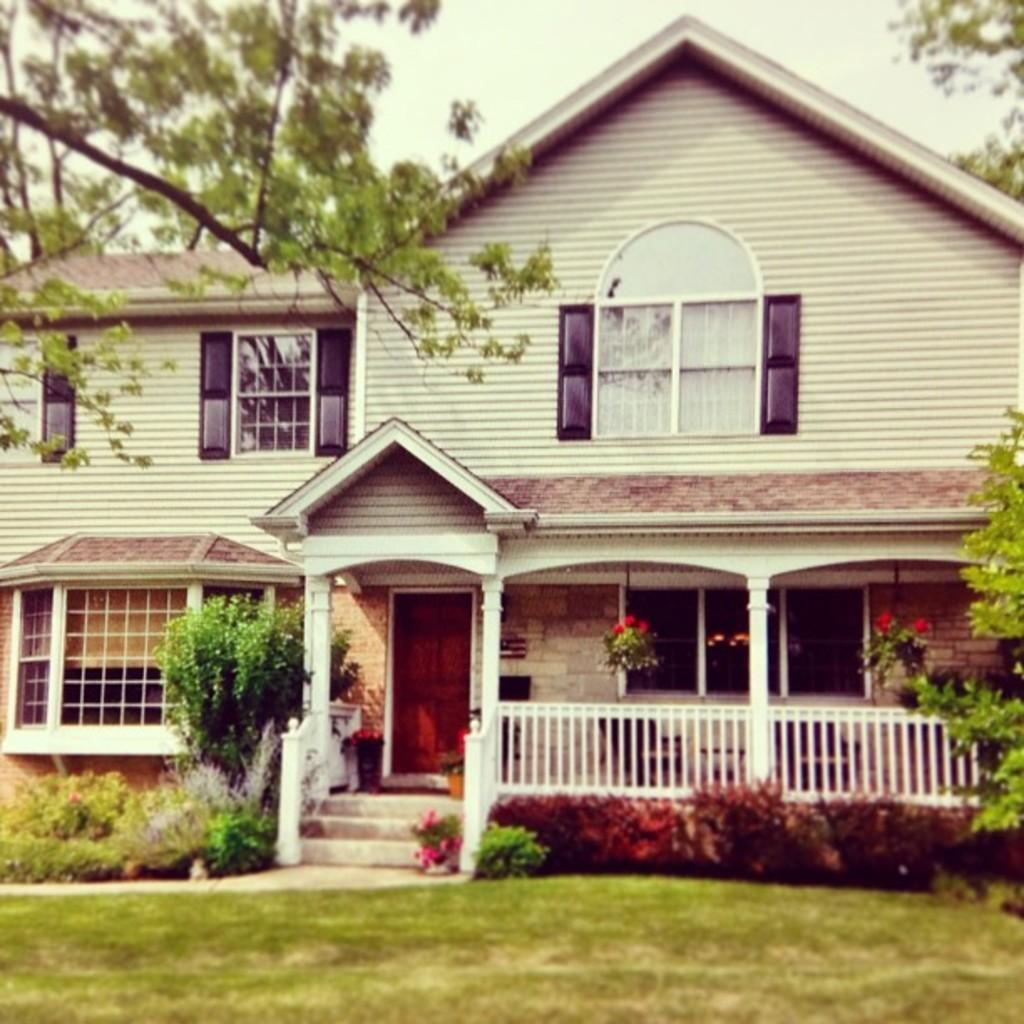What type of vegetation is present on the ground in the front of the image? There is grass on the ground in the front of the image. What can be seen in the background of the image? In the background of the image, there are plants, trees, and a house. What is the condition of the sky in the image? The sky is cloudy in the image. What type of decision can be seen being made by the seat in the image? There is no seat present in the image, and therefore no decision-making can be observed. 